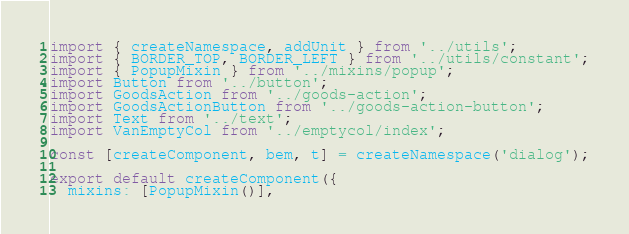<code> <loc_0><loc_0><loc_500><loc_500><_JavaScript_>import { createNamespace, addUnit } from '../utils';
import { BORDER_TOP, BORDER_LEFT } from '../utils/constant';
import { PopupMixin } from '../mixins/popup';
import Button from '../button';
import GoodsAction from '../goods-action';
import GoodsActionButton from '../goods-action-button';
import Text from '../text';
import VanEmptyCol from '../emptycol/index';

const [createComponent, bem, t] = createNamespace('dialog');

export default createComponent({
  mixins: [PopupMixin()],</code> 